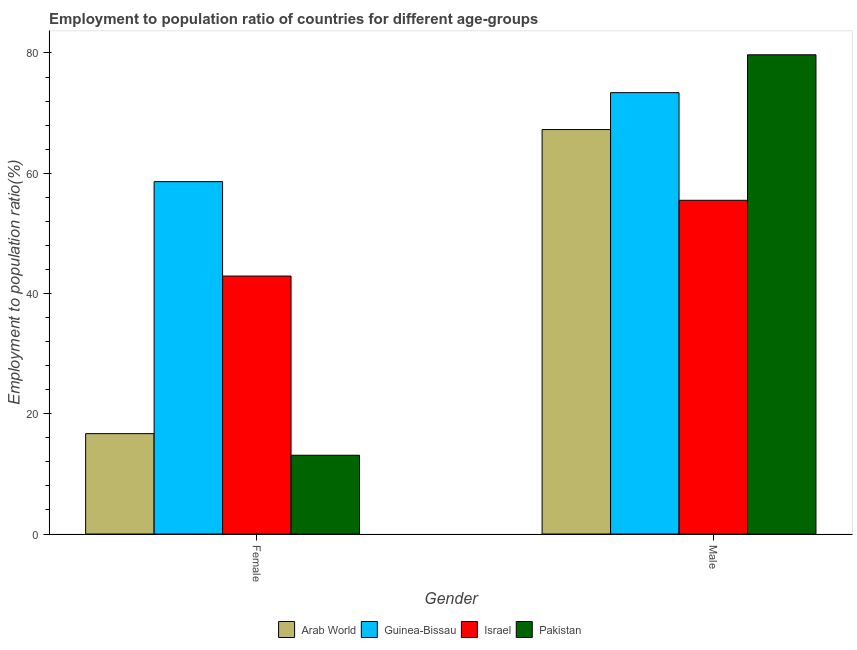How many different coloured bars are there?
Offer a very short reply. 4. How many groups of bars are there?
Give a very brief answer. 2. Are the number of bars on each tick of the X-axis equal?
Your response must be concise. Yes. How many bars are there on the 2nd tick from the left?
Ensure brevity in your answer.  4. How many bars are there on the 2nd tick from the right?
Your response must be concise. 4. What is the employment to population ratio(male) in Israel?
Ensure brevity in your answer.  55.5. Across all countries, what is the maximum employment to population ratio(female)?
Make the answer very short. 58.6. Across all countries, what is the minimum employment to population ratio(female)?
Your answer should be very brief. 13.1. In which country was the employment to population ratio(female) minimum?
Keep it short and to the point. Pakistan. What is the total employment to population ratio(female) in the graph?
Your answer should be very brief. 131.29. What is the difference between the employment to population ratio(female) in Israel and that in Arab World?
Ensure brevity in your answer.  26.21. What is the difference between the employment to population ratio(female) in Arab World and the employment to population ratio(male) in Israel?
Make the answer very short. -38.81. What is the average employment to population ratio(male) per country?
Your response must be concise. 68.97. What is the difference between the employment to population ratio(male) and employment to population ratio(female) in Israel?
Offer a terse response. 12.6. What is the ratio of the employment to population ratio(male) in Arab World to that in Guinea-Bissau?
Offer a very short reply. 0.92. In how many countries, is the employment to population ratio(male) greater than the average employment to population ratio(male) taken over all countries?
Your response must be concise. 2. What does the 2nd bar from the left in Male represents?
Make the answer very short. Guinea-Bissau. What does the 4th bar from the right in Male represents?
Keep it short and to the point. Arab World. How many bars are there?
Your answer should be compact. 8. Are all the bars in the graph horizontal?
Offer a terse response. No. Where does the legend appear in the graph?
Offer a terse response. Bottom center. How many legend labels are there?
Provide a short and direct response. 4. How are the legend labels stacked?
Your answer should be very brief. Horizontal. What is the title of the graph?
Give a very brief answer. Employment to population ratio of countries for different age-groups. What is the Employment to population ratio(%) in Arab World in Female?
Ensure brevity in your answer.  16.69. What is the Employment to population ratio(%) in Guinea-Bissau in Female?
Provide a short and direct response. 58.6. What is the Employment to population ratio(%) in Israel in Female?
Your answer should be compact. 42.9. What is the Employment to population ratio(%) of Pakistan in Female?
Provide a succinct answer. 13.1. What is the Employment to population ratio(%) of Arab World in Male?
Keep it short and to the point. 67.26. What is the Employment to population ratio(%) of Guinea-Bissau in Male?
Your answer should be very brief. 73.4. What is the Employment to population ratio(%) of Israel in Male?
Your response must be concise. 55.5. What is the Employment to population ratio(%) in Pakistan in Male?
Your answer should be compact. 79.7. Across all Gender, what is the maximum Employment to population ratio(%) in Arab World?
Ensure brevity in your answer.  67.26. Across all Gender, what is the maximum Employment to population ratio(%) of Guinea-Bissau?
Ensure brevity in your answer.  73.4. Across all Gender, what is the maximum Employment to population ratio(%) of Israel?
Your response must be concise. 55.5. Across all Gender, what is the maximum Employment to population ratio(%) of Pakistan?
Your answer should be very brief. 79.7. Across all Gender, what is the minimum Employment to population ratio(%) of Arab World?
Offer a very short reply. 16.69. Across all Gender, what is the minimum Employment to population ratio(%) of Guinea-Bissau?
Keep it short and to the point. 58.6. Across all Gender, what is the minimum Employment to population ratio(%) of Israel?
Provide a short and direct response. 42.9. Across all Gender, what is the minimum Employment to population ratio(%) of Pakistan?
Keep it short and to the point. 13.1. What is the total Employment to population ratio(%) of Arab World in the graph?
Give a very brief answer. 83.96. What is the total Employment to population ratio(%) in Guinea-Bissau in the graph?
Offer a very short reply. 132. What is the total Employment to population ratio(%) of Israel in the graph?
Your answer should be very brief. 98.4. What is the total Employment to population ratio(%) in Pakistan in the graph?
Your answer should be compact. 92.8. What is the difference between the Employment to population ratio(%) of Arab World in Female and that in Male?
Offer a terse response. -50.57. What is the difference between the Employment to population ratio(%) in Guinea-Bissau in Female and that in Male?
Offer a terse response. -14.8. What is the difference between the Employment to population ratio(%) of Pakistan in Female and that in Male?
Offer a terse response. -66.6. What is the difference between the Employment to population ratio(%) in Arab World in Female and the Employment to population ratio(%) in Guinea-Bissau in Male?
Keep it short and to the point. -56.71. What is the difference between the Employment to population ratio(%) in Arab World in Female and the Employment to population ratio(%) in Israel in Male?
Offer a terse response. -38.81. What is the difference between the Employment to population ratio(%) of Arab World in Female and the Employment to population ratio(%) of Pakistan in Male?
Your response must be concise. -63.01. What is the difference between the Employment to population ratio(%) of Guinea-Bissau in Female and the Employment to population ratio(%) of Pakistan in Male?
Keep it short and to the point. -21.1. What is the difference between the Employment to population ratio(%) of Israel in Female and the Employment to population ratio(%) of Pakistan in Male?
Ensure brevity in your answer.  -36.8. What is the average Employment to population ratio(%) in Arab World per Gender?
Offer a very short reply. 41.98. What is the average Employment to population ratio(%) in Guinea-Bissau per Gender?
Make the answer very short. 66. What is the average Employment to population ratio(%) in Israel per Gender?
Your response must be concise. 49.2. What is the average Employment to population ratio(%) of Pakistan per Gender?
Ensure brevity in your answer.  46.4. What is the difference between the Employment to population ratio(%) of Arab World and Employment to population ratio(%) of Guinea-Bissau in Female?
Keep it short and to the point. -41.91. What is the difference between the Employment to population ratio(%) of Arab World and Employment to population ratio(%) of Israel in Female?
Give a very brief answer. -26.21. What is the difference between the Employment to population ratio(%) of Arab World and Employment to population ratio(%) of Pakistan in Female?
Keep it short and to the point. 3.59. What is the difference between the Employment to population ratio(%) in Guinea-Bissau and Employment to population ratio(%) in Israel in Female?
Your response must be concise. 15.7. What is the difference between the Employment to population ratio(%) of Guinea-Bissau and Employment to population ratio(%) of Pakistan in Female?
Offer a terse response. 45.5. What is the difference between the Employment to population ratio(%) of Israel and Employment to population ratio(%) of Pakistan in Female?
Offer a terse response. 29.8. What is the difference between the Employment to population ratio(%) in Arab World and Employment to population ratio(%) in Guinea-Bissau in Male?
Provide a succinct answer. -6.14. What is the difference between the Employment to population ratio(%) in Arab World and Employment to population ratio(%) in Israel in Male?
Your answer should be compact. 11.76. What is the difference between the Employment to population ratio(%) in Arab World and Employment to population ratio(%) in Pakistan in Male?
Your answer should be very brief. -12.44. What is the difference between the Employment to population ratio(%) in Israel and Employment to population ratio(%) in Pakistan in Male?
Give a very brief answer. -24.2. What is the ratio of the Employment to population ratio(%) of Arab World in Female to that in Male?
Make the answer very short. 0.25. What is the ratio of the Employment to population ratio(%) of Guinea-Bissau in Female to that in Male?
Provide a succinct answer. 0.8. What is the ratio of the Employment to population ratio(%) in Israel in Female to that in Male?
Ensure brevity in your answer.  0.77. What is the ratio of the Employment to population ratio(%) in Pakistan in Female to that in Male?
Your answer should be compact. 0.16. What is the difference between the highest and the second highest Employment to population ratio(%) of Arab World?
Your response must be concise. 50.57. What is the difference between the highest and the second highest Employment to population ratio(%) of Guinea-Bissau?
Provide a short and direct response. 14.8. What is the difference between the highest and the second highest Employment to population ratio(%) in Pakistan?
Keep it short and to the point. 66.6. What is the difference between the highest and the lowest Employment to population ratio(%) of Arab World?
Your response must be concise. 50.57. What is the difference between the highest and the lowest Employment to population ratio(%) of Israel?
Ensure brevity in your answer.  12.6. What is the difference between the highest and the lowest Employment to population ratio(%) of Pakistan?
Give a very brief answer. 66.6. 